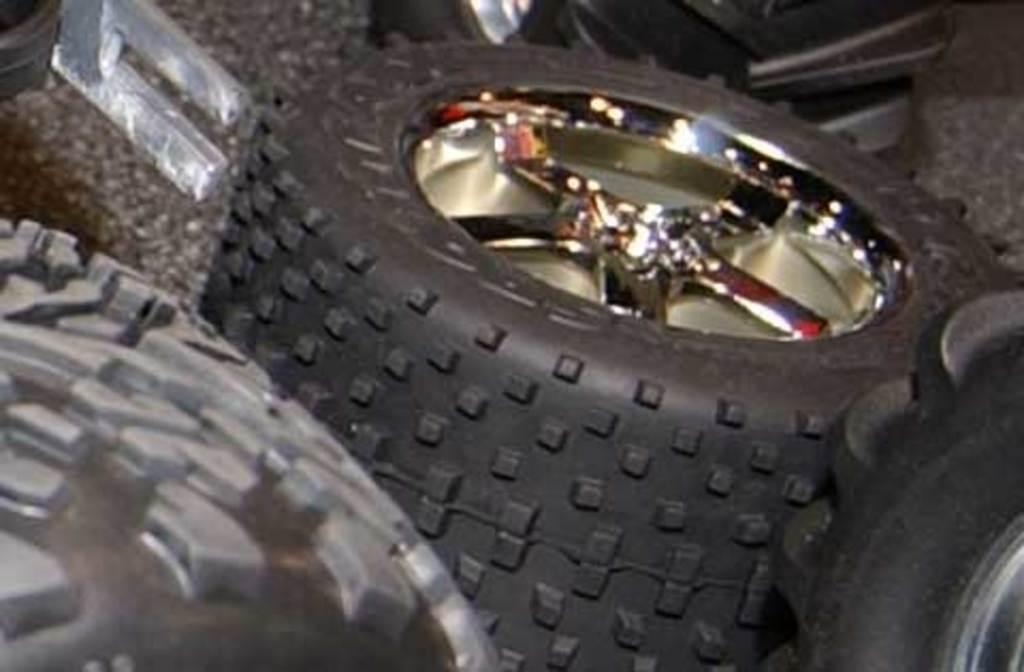What type of objects can be seen in the image? There are tyres in the image. Can you describe the location of these objects? The tyres are on the floor in the image. What color is the daughter's sweater in the image? There is no daughter or sweater present in the image. 